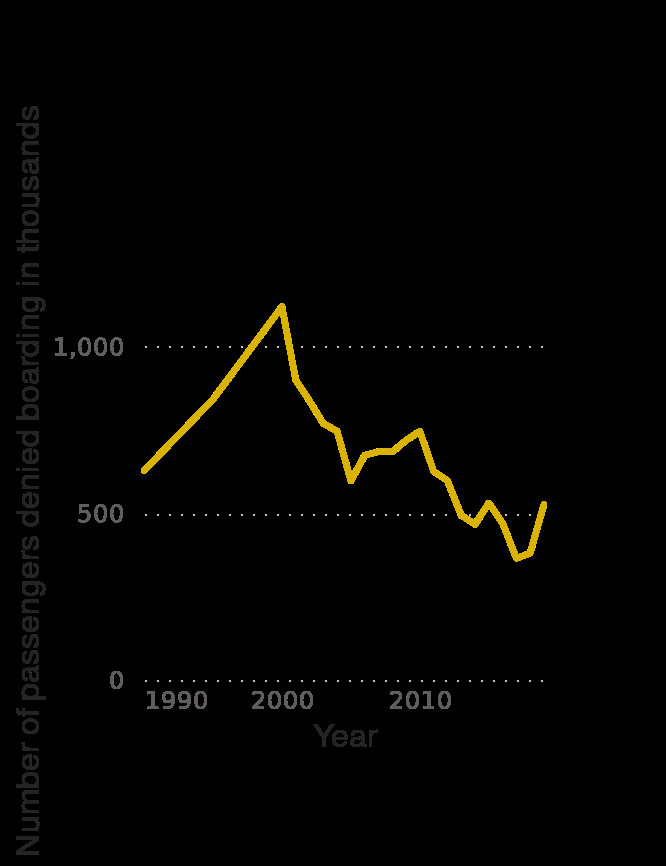<image>
When did the number of passengers denied boarding reach its highest point? The number of passengers denied boarding reached its highest point in the early 2000s. Did the number of passengers denied boarding increase or decrease after its peak in the early 2000s?  After its peak in the early 2000s, the number of passengers denied boarding has shown a downward trend. How has the number of passengers denied boarding by the largest U.S. air carriers changed over time?  The number of passengers denied boarding by the largest U.S. air carriers has varied over the years, as shown by the line plot.  